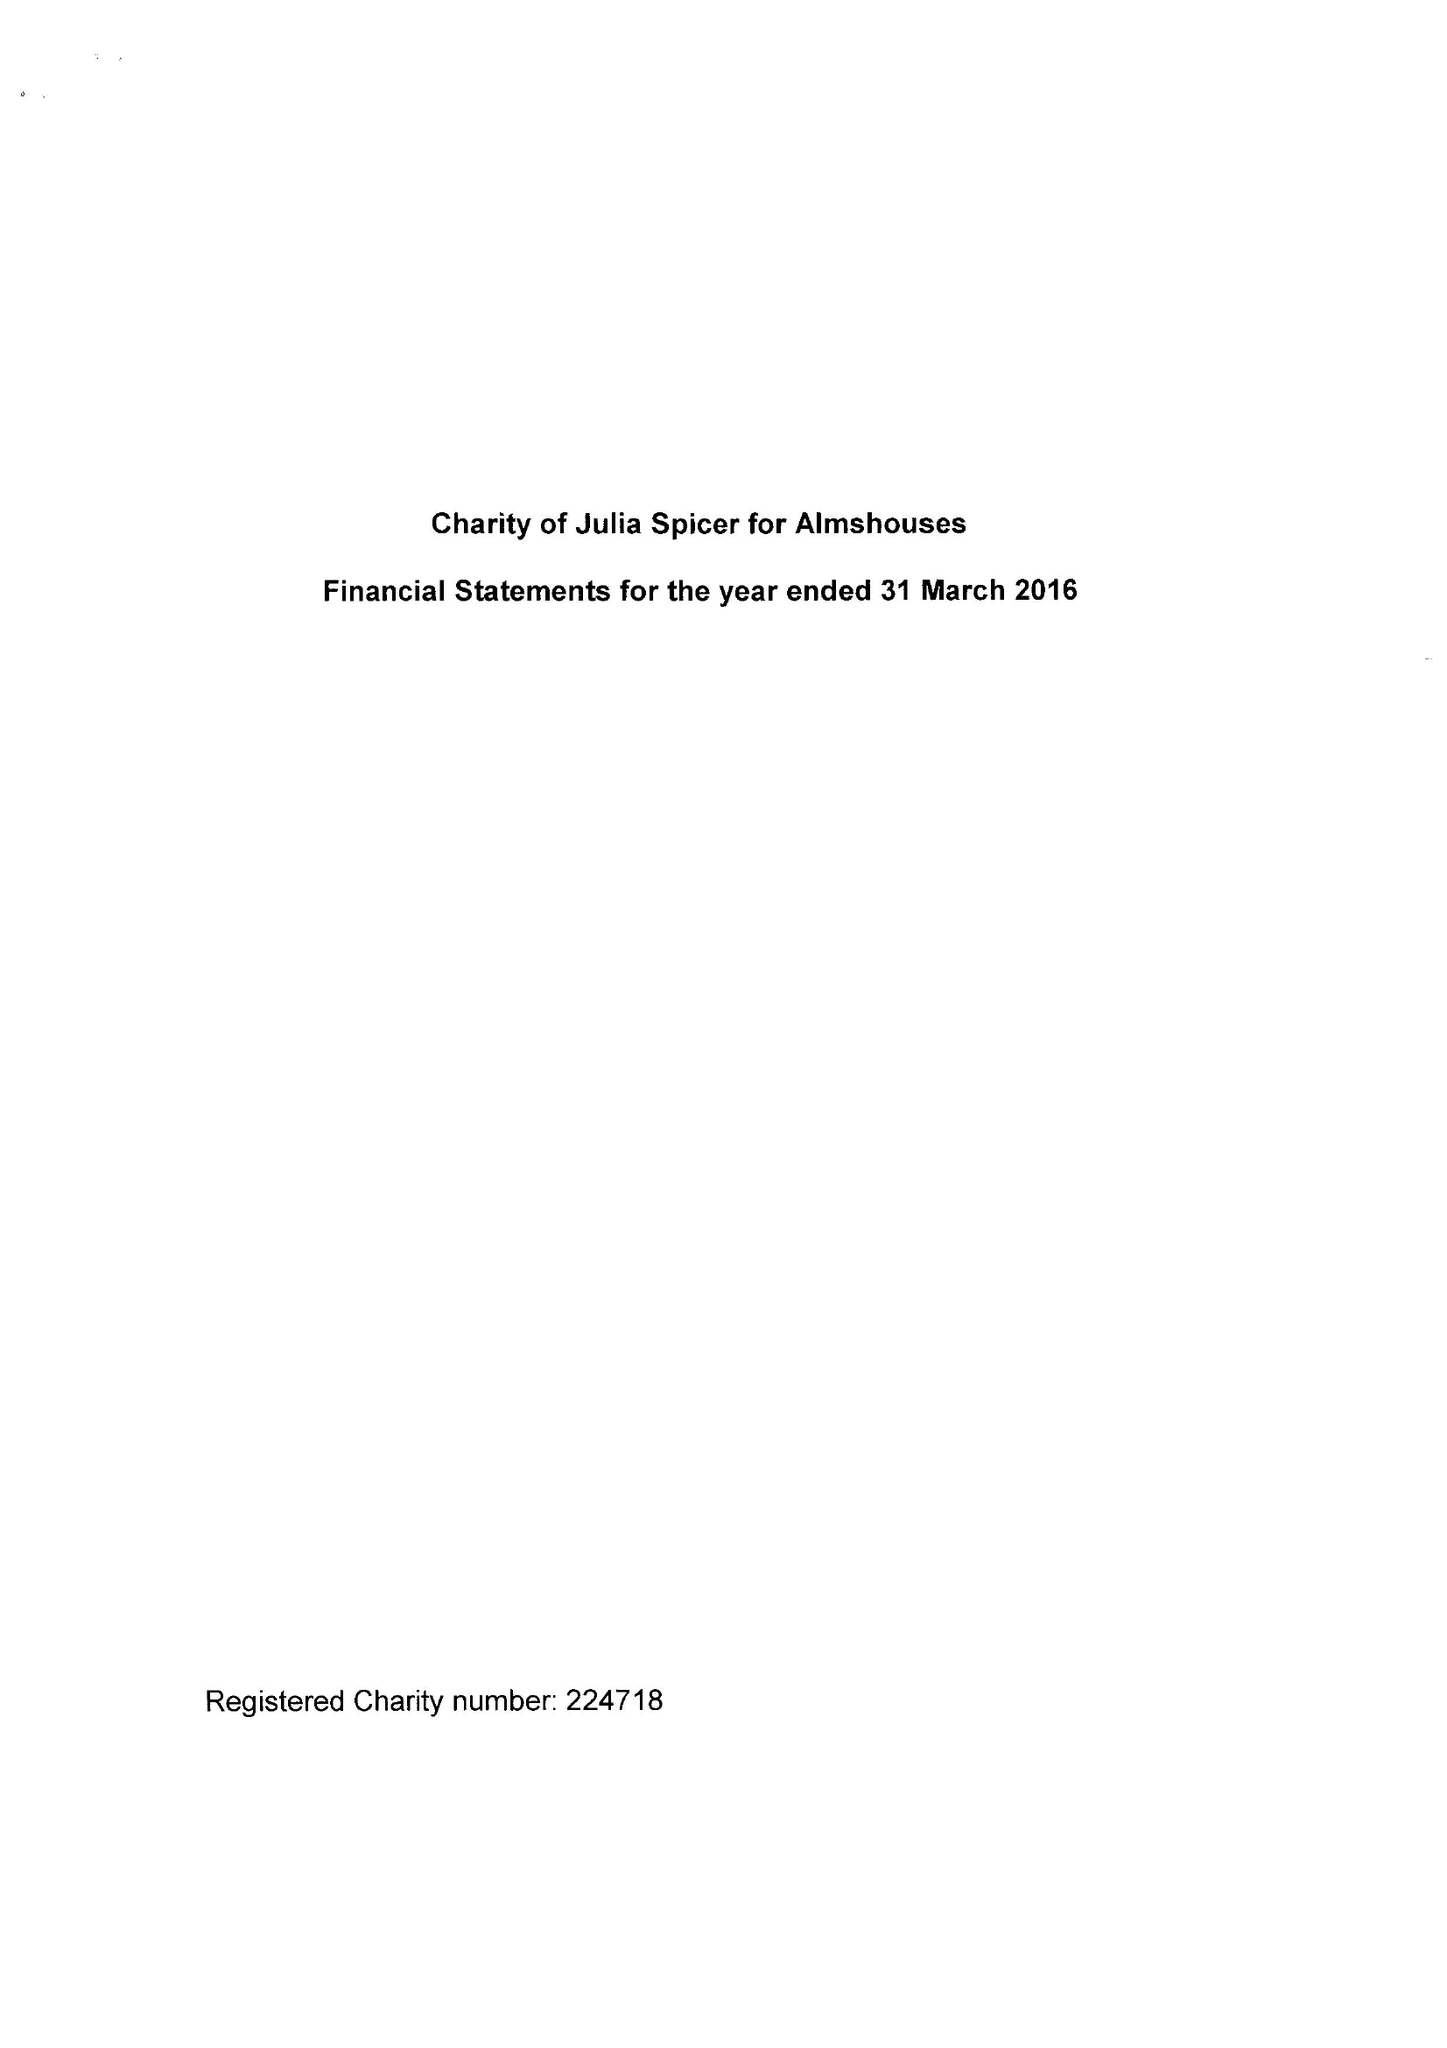What is the value for the report_date?
Answer the question using a single word or phrase. 2016-03-31 